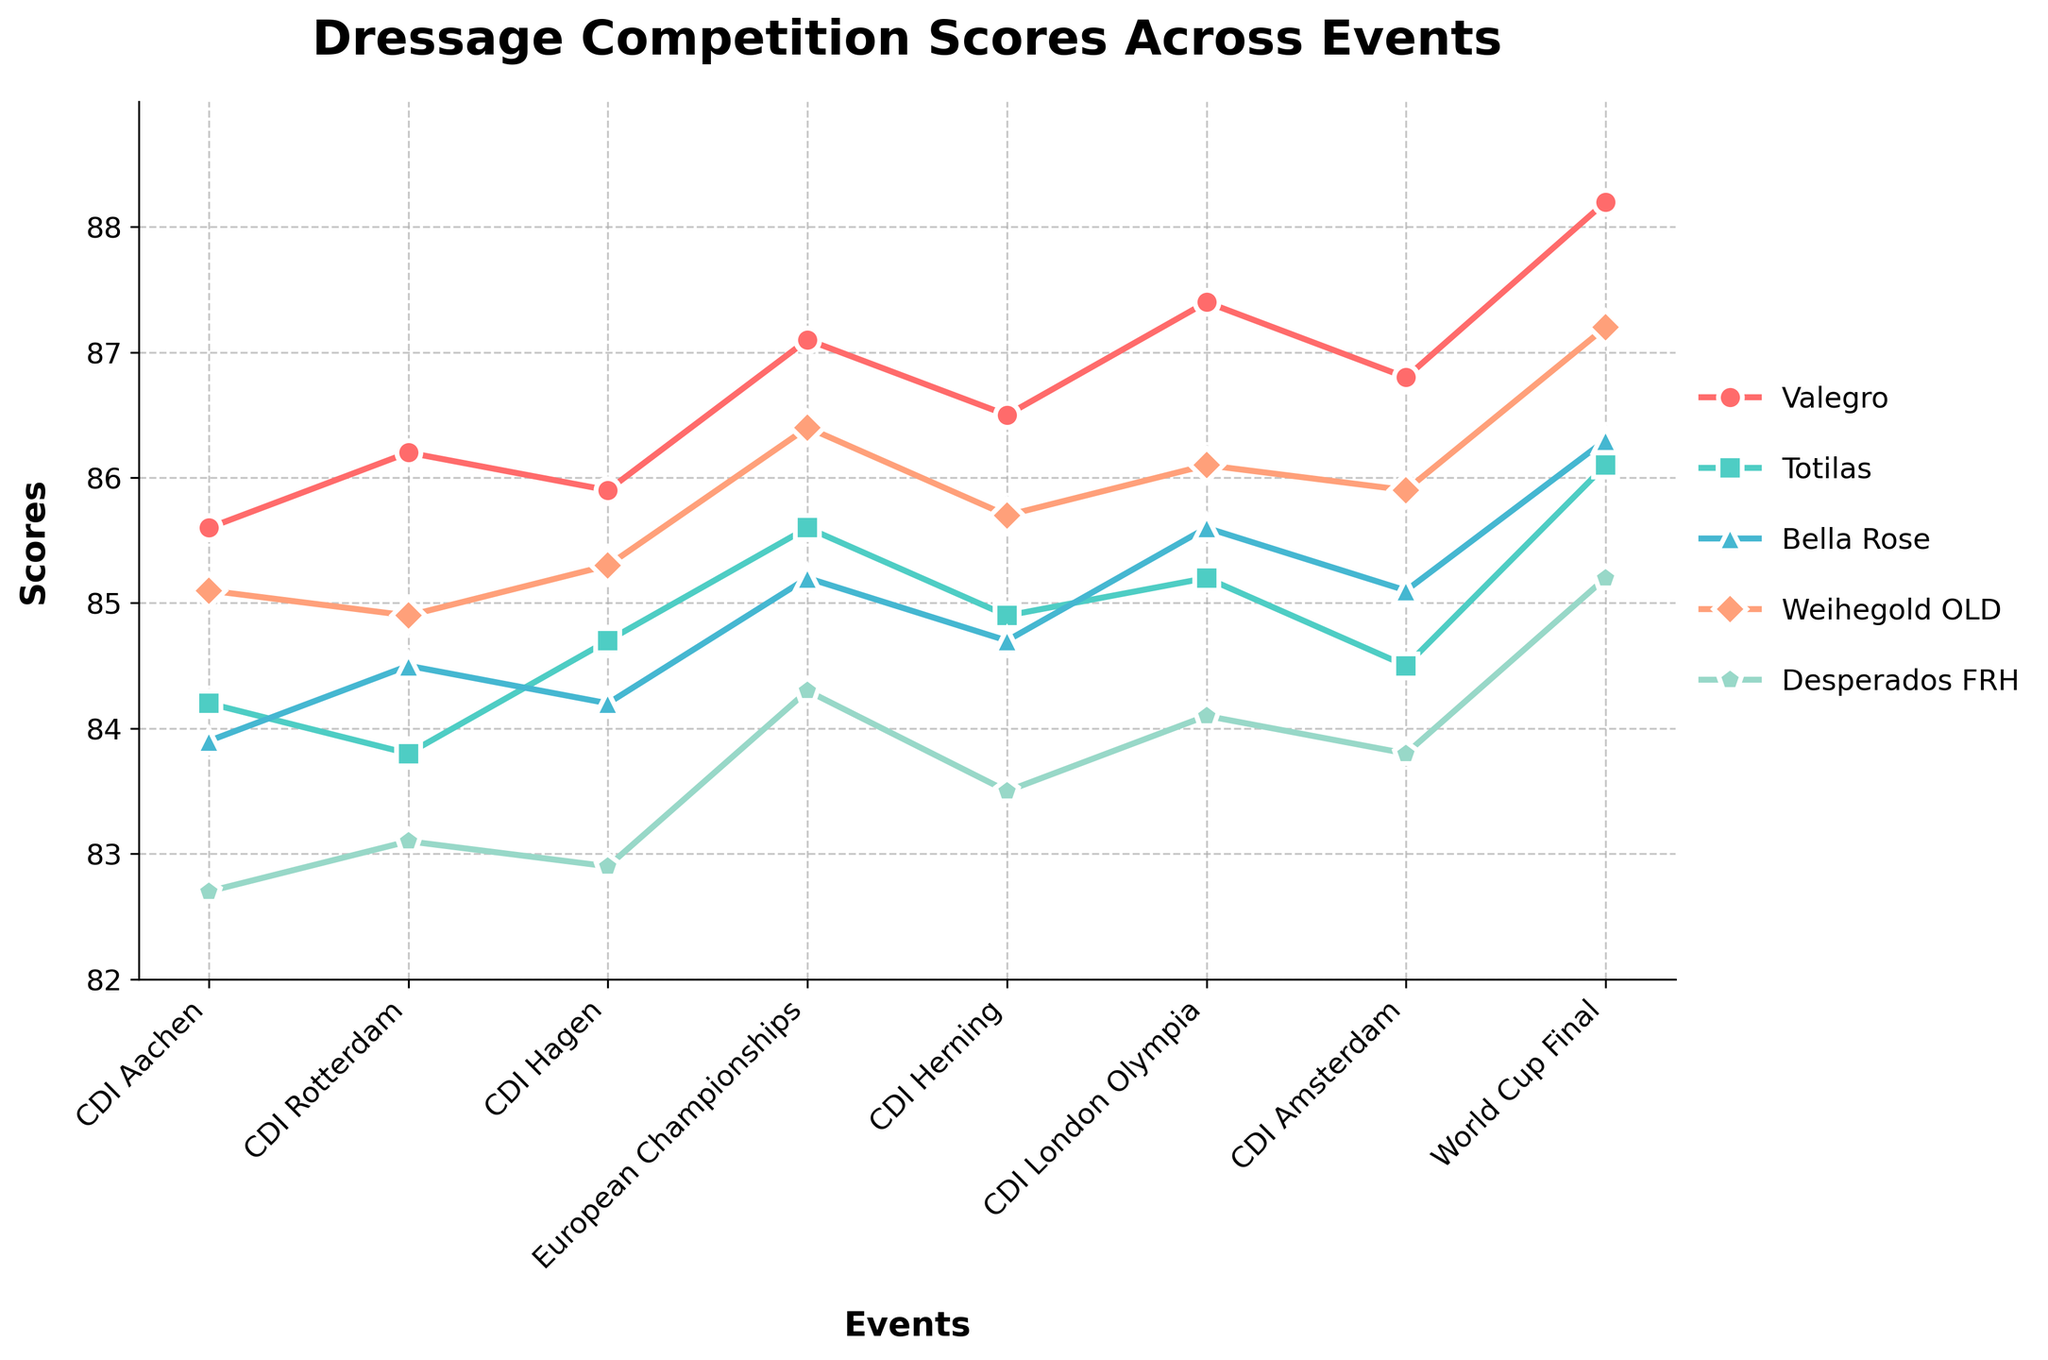What event did Valegro score the highest? Look at the line for Valegro and find the highest point. The highest score for Valegro is at the World Cup Final.
Answer: World Cup Final Which horse had the lowest score overall, and what was it? Look at the lowest point of all the lines. The lowest score is 82.7, which belongs to Desperados FRH at CDI Aachen.
Answer: Desperados FRH, 82.7 How much higher was Valegro's highest score compared to his lowest score? Find the highest (88.2 at World Cup Final) and lowest score (85.6 at CDI Aachen) for Valegro. The difference is 88.2 - 85.6.
Answer: 2.6 Which event had the most varied scores among the horses? Compare the range of scores (highest minus lowest score) for each event. The largest range is at the World Cup Final, from 88.2 (Valegro) to 85.2 (Desperados FRH), which is 88.2 - 85.2.
Answer: World Cup Final At the European Championships, which two horses had the closest scores, and what were they? Look at the scores for each horse at the European Championships and find the closest pair of numbers. Weihegold OLD (86.4) and Bella Rose (85.2) are 1.2 apart. Totilas (85.6) and Bella Rose (85.2) are closer with a difference of 0.4.
Answer: Totilas and Bella Rose, 85.6 and 85.2 How did Totilas' scores compare with Bella Rose's scores on average across all events? For Totilas: (84.2 + 83.8 + 84.7 + 85.6 + 84.9 + 85.2 + 84.5 + 86.1) / 8. For Bella Rose: (83.9 + 84.5 + 84.2 + 85.2 + 84.7 + 85.6 + 85.1 + 86.3) / 8. Then compare these two averages.
Answer: Totilas: 84.88, Bella Rose: 84.94, Bella Rose slightly higher Which horse showed the most consistent performance, and how can you tell? Examine the variability of the scores for each horse. The smallest variability (least difference between highest and lowest scores) indicates consistency. Weihegold OLD scored between 84.9 and 87.2, showing moderate consistency, while Valegro had scores from 85.6 to 88.2. Desperados FRH showed less consistency with more varied scores.
Answer: Weihegold OLD In which event did both Totilas and Weihegold OLD achieve scores very close to each other? Compare Totilas and Weihegold OLD scores for each event and find where the difference is the smallest. At CDI Rotterdam, Totilas (83.8) and Weihegold OLD (84.9) are 1.1 apart. At CDI Amsterdam, Totilas (84.5) and Weihegold OLD (85.9) are 1.4 apart. The closest is at CDI Herning, with Totilas (84.9) and Weihegold OLD (85.7), a 0.8 difference.
Answer: CDI Herning What is the average score of Weihegold OLD over all events? Add up all of Weihegold OLD's scores and divide by the number of events: (85.1 + 84.9 + 85.3 + 86.4 + 85.7 + 86.1 + 85.9 + 87.2) / 8
Answer: 85.82 